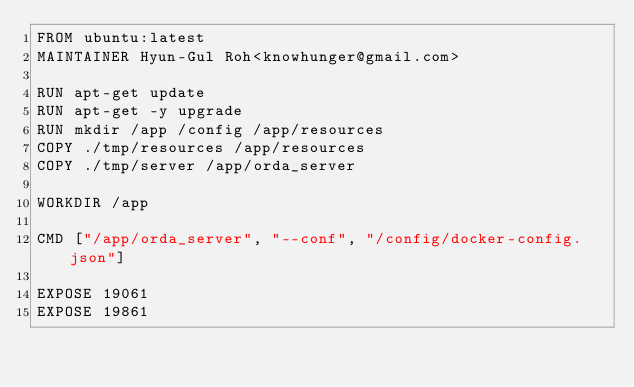<code> <loc_0><loc_0><loc_500><loc_500><_Dockerfile_>FROM ubuntu:latest
MAINTAINER Hyun-Gul Roh<knowhunger@gmail.com>

RUN apt-get update
RUN apt-get -y upgrade
RUN mkdir /app /config /app/resources
COPY ./tmp/resources /app/resources
COPY ./tmp/server /app/orda_server

WORKDIR /app

CMD ["/app/orda_server", "--conf", "/config/docker-config.json"]

EXPOSE 19061
EXPOSE 19861</code> 